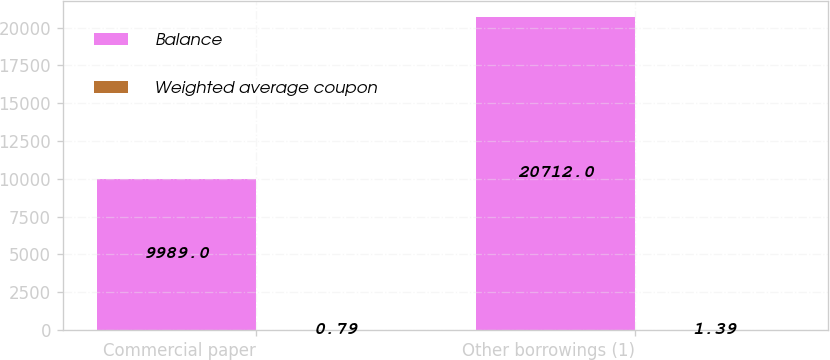Convert chart to OTSL. <chart><loc_0><loc_0><loc_500><loc_500><stacked_bar_chart><ecel><fcel>Commercial paper<fcel>Other borrowings (1)<nl><fcel>Balance<fcel>9989<fcel>20712<nl><fcel>Weighted average coupon<fcel>0.79<fcel>1.39<nl></chart> 